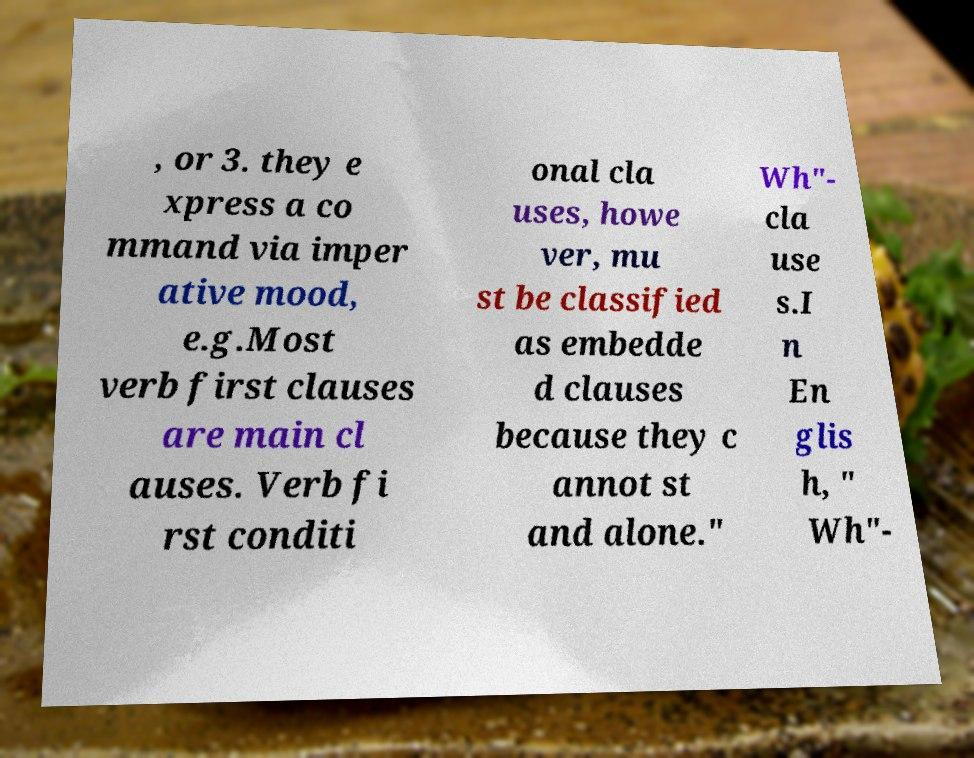Could you extract and type out the text from this image? , or 3. they e xpress a co mmand via imper ative mood, e.g.Most verb first clauses are main cl auses. Verb fi rst conditi onal cla uses, howe ver, mu st be classified as embedde d clauses because they c annot st and alone." Wh"- cla use s.I n En glis h, " Wh"- 